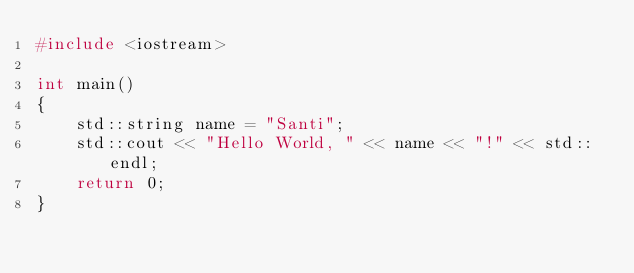<code> <loc_0><loc_0><loc_500><loc_500><_C++_>#include <iostream>

int main()
{
    std::string name = "Santi";
    std::cout << "Hello World, " << name << "!" << std::endl;
    return 0;
}
</code> 